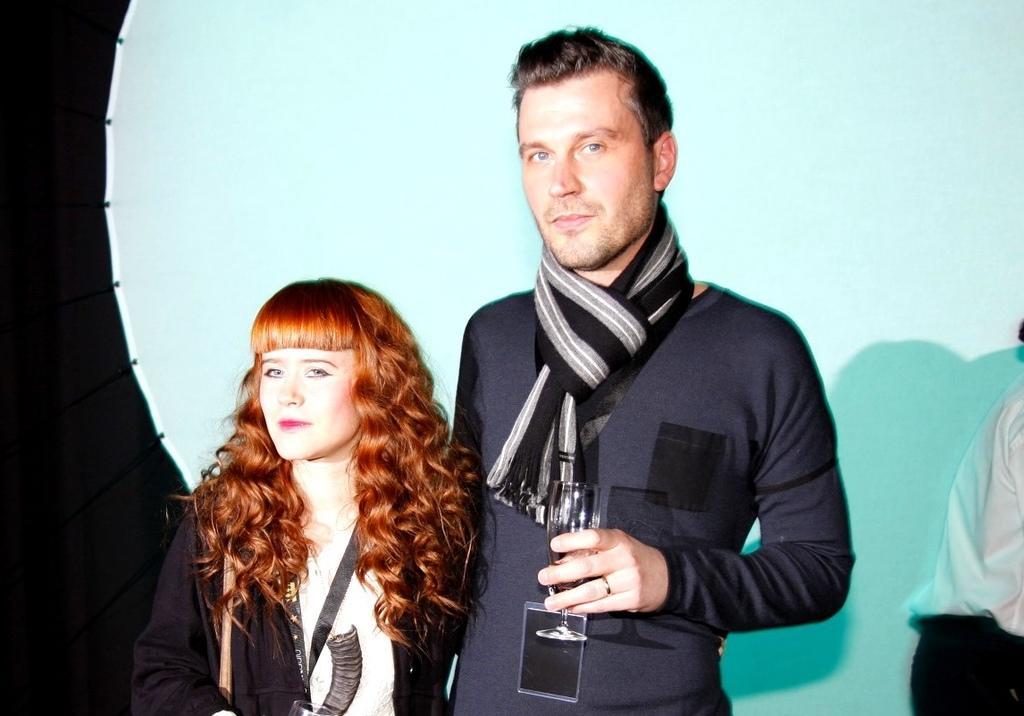How would you summarize this image in a sentence or two? In this image we can see a man and a woman. Both are holding glasses. Man is wearing scarf. In the back there is another person. 